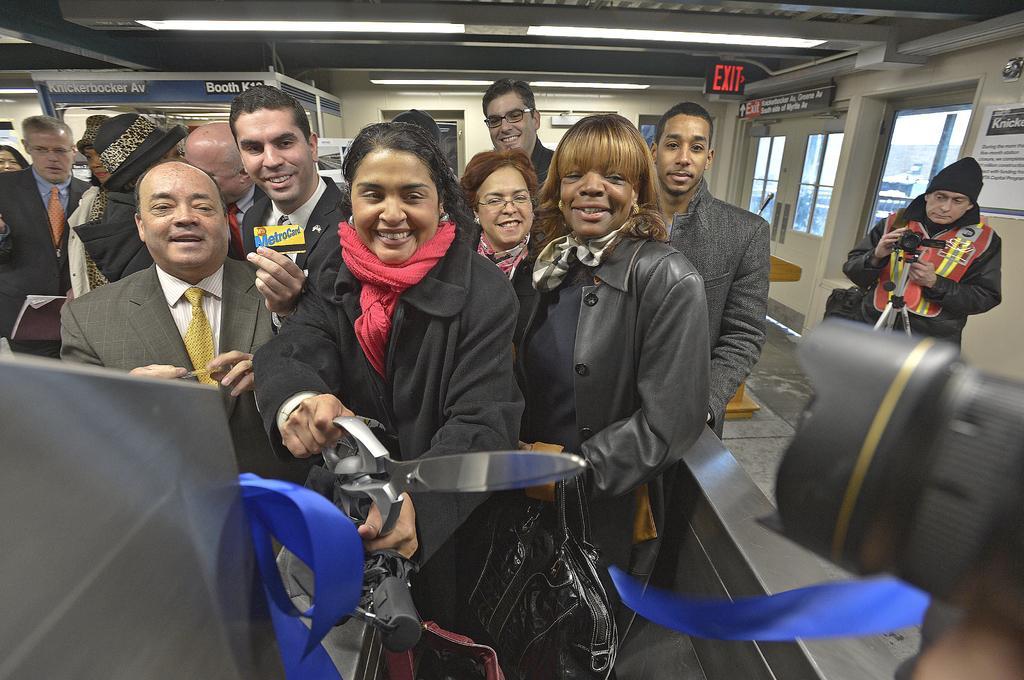How would you summarize this image in a sentence or two? In this image, we can see persons wearing clothes. There is a person in the middle of the image holding a scissor with her hands. There is a ribbon at the bottom of the image. There is an another person on the right side of the image holding a camera with his hand. There is a camera lens in the bottom right of the image. There are photos in the top right of the image. There are lights on the ceiling which is at the top of the image. 